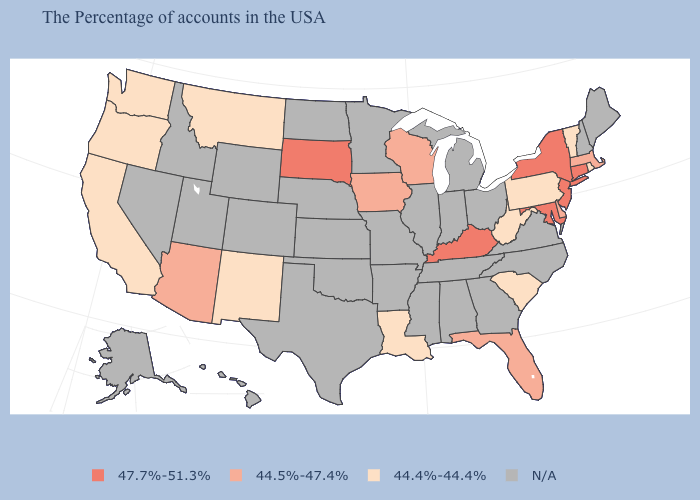Which states have the lowest value in the MidWest?
Keep it brief. Wisconsin, Iowa. Among the states that border Kentucky , which have the lowest value?
Concise answer only. West Virginia. What is the highest value in the USA?
Write a very short answer. 47.7%-51.3%. Name the states that have a value in the range N/A?
Concise answer only. Maine, New Hampshire, Virginia, North Carolina, Ohio, Georgia, Michigan, Indiana, Alabama, Tennessee, Illinois, Mississippi, Missouri, Arkansas, Minnesota, Kansas, Nebraska, Oklahoma, Texas, North Dakota, Wyoming, Colorado, Utah, Idaho, Nevada, Alaska, Hawaii. Name the states that have a value in the range 47.7%-51.3%?
Keep it brief. Connecticut, New York, New Jersey, Maryland, Kentucky, South Dakota. Which states have the lowest value in the USA?
Give a very brief answer. Rhode Island, Vermont, Pennsylvania, South Carolina, West Virginia, Louisiana, New Mexico, Montana, California, Washington, Oregon. Which states hav the highest value in the MidWest?
Quick response, please. South Dakota. Which states have the highest value in the USA?
Keep it brief. Connecticut, New York, New Jersey, Maryland, Kentucky, South Dakota. Name the states that have a value in the range N/A?
Keep it brief. Maine, New Hampshire, Virginia, North Carolina, Ohio, Georgia, Michigan, Indiana, Alabama, Tennessee, Illinois, Mississippi, Missouri, Arkansas, Minnesota, Kansas, Nebraska, Oklahoma, Texas, North Dakota, Wyoming, Colorado, Utah, Idaho, Nevada, Alaska, Hawaii. Does South Dakota have the lowest value in the MidWest?
Keep it brief. No. Name the states that have a value in the range 47.7%-51.3%?
Answer briefly. Connecticut, New York, New Jersey, Maryland, Kentucky, South Dakota. What is the lowest value in the South?
Be succinct. 44.4%-44.4%. Name the states that have a value in the range N/A?
Quick response, please. Maine, New Hampshire, Virginia, North Carolina, Ohio, Georgia, Michigan, Indiana, Alabama, Tennessee, Illinois, Mississippi, Missouri, Arkansas, Minnesota, Kansas, Nebraska, Oklahoma, Texas, North Dakota, Wyoming, Colorado, Utah, Idaho, Nevada, Alaska, Hawaii. Does New Jersey have the lowest value in the Northeast?
Answer briefly. No. What is the value of Montana?
Answer briefly. 44.4%-44.4%. 